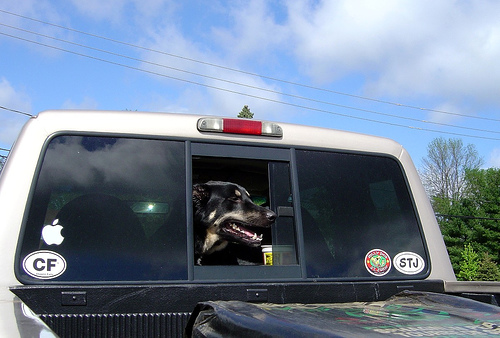<image>What company logo is on the top left of the truck window? I am not sure what company logo is on the top left of the truck window. It may be "apple" or there may not be any. What company logo is on the top left of the truck window? It can be seen 'apple' logo on the top left of the truck window. 